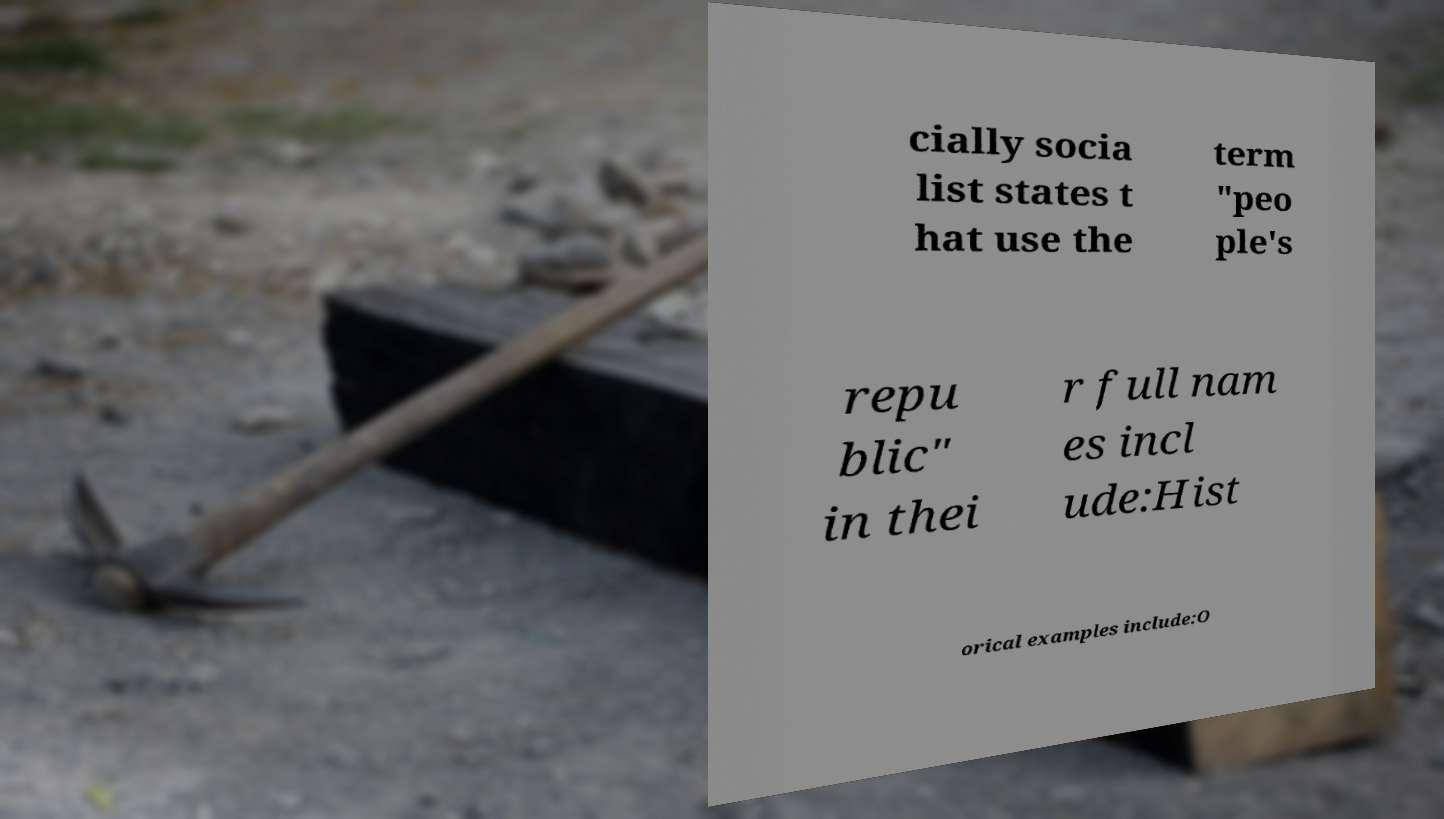Please identify and transcribe the text found in this image. cially socia list states t hat use the term "peo ple's repu blic" in thei r full nam es incl ude:Hist orical examples include:O 